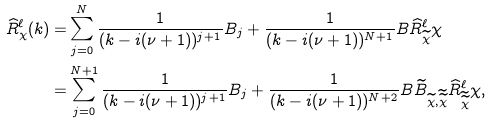Convert formula to latex. <formula><loc_0><loc_0><loc_500><loc_500>\widehat { R } _ { \chi } ^ { \ell } ( k ) = & \sum _ { j = 0 } ^ { N } \frac { 1 } { ( k - i ( \nu + 1 ) ) ^ { j + 1 } } B _ { j } + \frac { 1 } { ( k - i ( \nu + 1 ) ) ^ { N + 1 } } B \widehat { R } _ { \widetilde { \chi } } ^ { \ell } \chi \\ = & \sum _ { j = 0 } ^ { N + 1 } \frac { 1 } { ( k - i ( \nu + 1 ) ) ^ { j + 1 } } B _ { j } + \frac { 1 } { ( k - i ( \nu + 1 ) ) ^ { N + 2 } } B \widetilde { B } _ { \widetilde { \chi } , \widetilde { \widetilde { \chi } } } \widehat { R } _ { \widetilde { \widetilde { \chi } } } ^ { \ell } \chi ,</formula> 